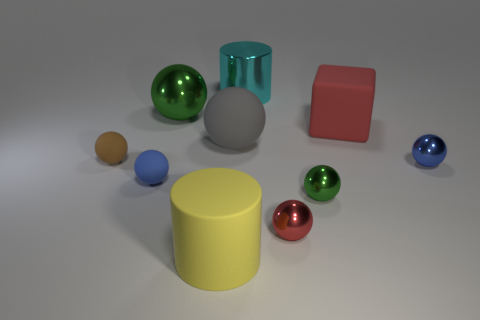Subtract all small brown balls. How many balls are left? 6 Subtract all blue spheres. How many spheres are left? 5 Subtract all blue balls. Subtract all yellow cubes. How many balls are left? 5 Subtract all spheres. How many objects are left? 3 Subtract all large gray spheres. Subtract all cyan cylinders. How many objects are left? 8 Add 3 big metallic spheres. How many big metallic spheres are left? 4 Add 8 large red cubes. How many large red cubes exist? 9 Subtract 1 brown balls. How many objects are left? 9 